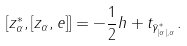<formula> <loc_0><loc_0><loc_500><loc_500>[ z _ { \alpha } ^ { * } , [ z _ { \alpha } , e ] ] = - \frac { 1 } { 2 } h + t _ { \bar { \gamma } ^ { * } _ { | \alpha | , \alpha } } .</formula> 